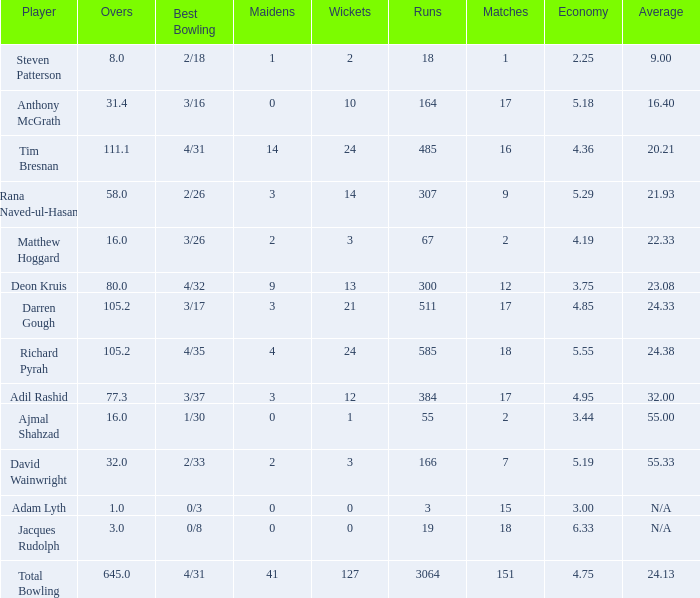What is the lowest Overs with a Run that is 18? 8.0. 